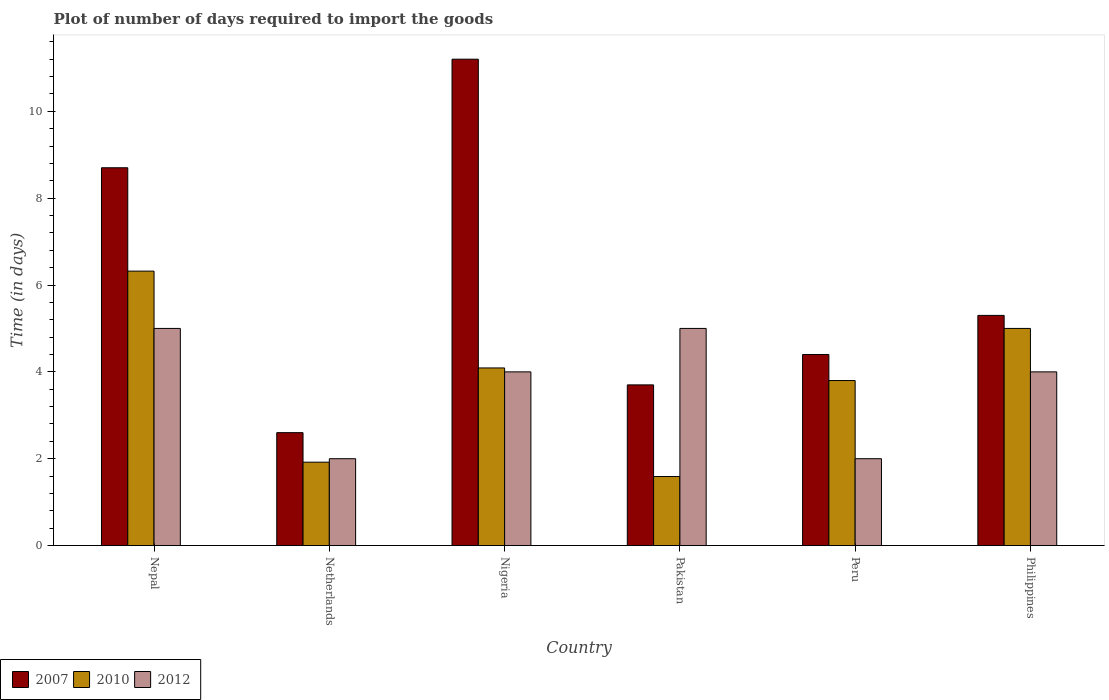Are the number of bars on each tick of the X-axis equal?
Make the answer very short. Yes. How many bars are there on the 5th tick from the right?
Offer a very short reply. 3. What is the label of the 5th group of bars from the left?
Offer a very short reply. Peru. What is the time required to import goods in 2007 in Nepal?
Give a very brief answer. 8.7. Across all countries, what is the minimum time required to import goods in 2010?
Offer a terse response. 1.59. In which country was the time required to import goods in 2007 maximum?
Ensure brevity in your answer.  Nigeria. In which country was the time required to import goods in 2007 minimum?
Provide a short and direct response. Netherlands. What is the difference between the time required to import goods in 2012 in Peru and that in Philippines?
Offer a terse response. -2. What is the difference between the time required to import goods in 2012 in Nepal and the time required to import goods in 2007 in Philippines?
Provide a succinct answer. -0.3. What is the average time required to import goods in 2010 per country?
Make the answer very short. 3.79. What is the difference between the time required to import goods of/in 2007 and time required to import goods of/in 2010 in Philippines?
Make the answer very short. 0.3. In how many countries, is the time required to import goods in 2007 greater than 8.8 days?
Provide a short and direct response. 1. What is the ratio of the time required to import goods in 2007 in Netherlands to that in Nigeria?
Ensure brevity in your answer.  0.23. Is the time required to import goods in 2007 in Nepal less than that in Nigeria?
Offer a very short reply. Yes. Is the difference between the time required to import goods in 2007 in Pakistan and Peru greater than the difference between the time required to import goods in 2010 in Pakistan and Peru?
Provide a succinct answer. Yes. What is the difference between the highest and the lowest time required to import goods in 2010?
Ensure brevity in your answer.  4.73. Is the sum of the time required to import goods in 2007 in Netherlands and Philippines greater than the maximum time required to import goods in 2010 across all countries?
Offer a terse response. Yes. What does the 3rd bar from the left in Pakistan represents?
Provide a short and direct response. 2012. How many bars are there?
Ensure brevity in your answer.  18. Are all the bars in the graph horizontal?
Keep it short and to the point. No. How many countries are there in the graph?
Your answer should be compact. 6. Are the values on the major ticks of Y-axis written in scientific E-notation?
Provide a succinct answer. No. Does the graph contain any zero values?
Offer a very short reply. No. How many legend labels are there?
Give a very brief answer. 3. How are the legend labels stacked?
Provide a short and direct response. Horizontal. What is the title of the graph?
Your answer should be very brief. Plot of number of days required to import the goods. Does "1986" appear as one of the legend labels in the graph?
Your answer should be very brief. No. What is the label or title of the X-axis?
Provide a succinct answer. Country. What is the label or title of the Y-axis?
Give a very brief answer. Time (in days). What is the Time (in days) of 2010 in Nepal?
Your answer should be very brief. 6.32. What is the Time (in days) in 2007 in Netherlands?
Give a very brief answer. 2.6. What is the Time (in days) in 2010 in Netherlands?
Provide a short and direct response. 1.92. What is the Time (in days) in 2012 in Netherlands?
Offer a very short reply. 2. What is the Time (in days) of 2010 in Nigeria?
Offer a terse response. 4.09. What is the Time (in days) in 2012 in Nigeria?
Make the answer very short. 4. What is the Time (in days) in 2007 in Pakistan?
Keep it short and to the point. 3.7. What is the Time (in days) in 2010 in Pakistan?
Offer a terse response. 1.59. What is the Time (in days) in 2007 in Peru?
Make the answer very short. 4.4. What is the Time (in days) in 2010 in Peru?
Provide a succinct answer. 3.8. What is the Time (in days) in 2010 in Philippines?
Your response must be concise. 5. What is the Time (in days) of 2012 in Philippines?
Provide a succinct answer. 4. Across all countries, what is the maximum Time (in days) of 2007?
Keep it short and to the point. 11.2. Across all countries, what is the maximum Time (in days) of 2010?
Offer a terse response. 6.32. Across all countries, what is the maximum Time (in days) of 2012?
Offer a very short reply. 5. Across all countries, what is the minimum Time (in days) of 2007?
Keep it short and to the point. 2.6. Across all countries, what is the minimum Time (in days) in 2010?
Offer a very short reply. 1.59. Across all countries, what is the minimum Time (in days) of 2012?
Your answer should be compact. 2. What is the total Time (in days) of 2007 in the graph?
Make the answer very short. 35.9. What is the total Time (in days) in 2010 in the graph?
Ensure brevity in your answer.  22.72. What is the total Time (in days) of 2012 in the graph?
Give a very brief answer. 22. What is the difference between the Time (in days) in 2007 in Nepal and that in Netherlands?
Offer a very short reply. 6.1. What is the difference between the Time (in days) of 2012 in Nepal and that in Netherlands?
Offer a terse response. 3. What is the difference between the Time (in days) of 2010 in Nepal and that in Nigeria?
Your response must be concise. 2.23. What is the difference between the Time (in days) in 2007 in Nepal and that in Pakistan?
Ensure brevity in your answer.  5. What is the difference between the Time (in days) of 2010 in Nepal and that in Pakistan?
Offer a very short reply. 4.73. What is the difference between the Time (in days) in 2010 in Nepal and that in Peru?
Give a very brief answer. 2.52. What is the difference between the Time (in days) in 2010 in Nepal and that in Philippines?
Keep it short and to the point. 1.32. What is the difference between the Time (in days) in 2012 in Nepal and that in Philippines?
Your answer should be very brief. 1. What is the difference between the Time (in days) in 2007 in Netherlands and that in Nigeria?
Your response must be concise. -8.6. What is the difference between the Time (in days) in 2010 in Netherlands and that in Nigeria?
Keep it short and to the point. -2.17. What is the difference between the Time (in days) in 2007 in Netherlands and that in Pakistan?
Your answer should be compact. -1.1. What is the difference between the Time (in days) in 2010 in Netherlands and that in Pakistan?
Your answer should be compact. 0.33. What is the difference between the Time (in days) of 2012 in Netherlands and that in Pakistan?
Your response must be concise. -3. What is the difference between the Time (in days) of 2007 in Netherlands and that in Peru?
Ensure brevity in your answer.  -1.8. What is the difference between the Time (in days) of 2010 in Netherlands and that in Peru?
Give a very brief answer. -1.88. What is the difference between the Time (in days) in 2010 in Netherlands and that in Philippines?
Provide a succinct answer. -3.08. What is the difference between the Time (in days) of 2007 in Nigeria and that in Pakistan?
Provide a succinct answer. 7.5. What is the difference between the Time (in days) of 2010 in Nigeria and that in Peru?
Offer a very short reply. 0.29. What is the difference between the Time (in days) of 2012 in Nigeria and that in Peru?
Offer a very short reply. 2. What is the difference between the Time (in days) in 2010 in Nigeria and that in Philippines?
Keep it short and to the point. -0.91. What is the difference between the Time (in days) of 2012 in Nigeria and that in Philippines?
Offer a very short reply. 0. What is the difference between the Time (in days) in 2007 in Pakistan and that in Peru?
Ensure brevity in your answer.  -0.7. What is the difference between the Time (in days) of 2010 in Pakistan and that in Peru?
Offer a very short reply. -2.21. What is the difference between the Time (in days) of 2007 in Pakistan and that in Philippines?
Ensure brevity in your answer.  -1.6. What is the difference between the Time (in days) of 2010 in Pakistan and that in Philippines?
Your answer should be very brief. -3.41. What is the difference between the Time (in days) in 2012 in Peru and that in Philippines?
Provide a succinct answer. -2. What is the difference between the Time (in days) of 2007 in Nepal and the Time (in days) of 2010 in Netherlands?
Keep it short and to the point. 6.78. What is the difference between the Time (in days) in 2007 in Nepal and the Time (in days) in 2012 in Netherlands?
Your answer should be compact. 6.7. What is the difference between the Time (in days) in 2010 in Nepal and the Time (in days) in 2012 in Netherlands?
Offer a terse response. 4.32. What is the difference between the Time (in days) in 2007 in Nepal and the Time (in days) in 2010 in Nigeria?
Your answer should be very brief. 4.61. What is the difference between the Time (in days) of 2010 in Nepal and the Time (in days) of 2012 in Nigeria?
Ensure brevity in your answer.  2.32. What is the difference between the Time (in days) of 2007 in Nepal and the Time (in days) of 2010 in Pakistan?
Provide a short and direct response. 7.11. What is the difference between the Time (in days) of 2010 in Nepal and the Time (in days) of 2012 in Pakistan?
Offer a very short reply. 1.32. What is the difference between the Time (in days) in 2007 in Nepal and the Time (in days) in 2012 in Peru?
Ensure brevity in your answer.  6.7. What is the difference between the Time (in days) in 2010 in Nepal and the Time (in days) in 2012 in Peru?
Your answer should be compact. 4.32. What is the difference between the Time (in days) in 2007 in Nepal and the Time (in days) in 2010 in Philippines?
Provide a short and direct response. 3.7. What is the difference between the Time (in days) of 2010 in Nepal and the Time (in days) of 2012 in Philippines?
Your answer should be compact. 2.32. What is the difference between the Time (in days) of 2007 in Netherlands and the Time (in days) of 2010 in Nigeria?
Provide a short and direct response. -1.49. What is the difference between the Time (in days) in 2010 in Netherlands and the Time (in days) in 2012 in Nigeria?
Your response must be concise. -2.08. What is the difference between the Time (in days) in 2007 in Netherlands and the Time (in days) in 2010 in Pakistan?
Your answer should be compact. 1.01. What is the difference between the Time (in days) of 2007 in Netherlands and the Time (in days) of 2012 in Pakistan?
Give a very brief answer. -2.4. What is the difference between the Time (in days) of 2010 in Netherlands and the Time (in days) of 2012 in Pakistan?
Your answer should be compact. -3.08. What is the difference between the Time (in days) in 2007 in Netherlands and the Time (in days) in 2010 in Peru?
Provide a short and direct response. -1.2. What is the difference between the Time (in days) of 2007 in Netherlands and the Time (in days) of 2012 in Peru?
Provide a succinct answer. 0.6. What is the difference between the Time (in days) in 2010 in Netherlands and the Time (in days) in 2012 in Peru?
Keep it short and to the point. -0.08. What is the difference between the Time (in days) in 2007 in Netherlands and the Time (in days) in 2010 in Philippines?
Offer a terse response. -2.4. What is the difference between the Time (in days) of 2007 in Netherlands and the Time (in days) of 2012 in Philippines?
Give a very brief answer. -1.4. What is the difference between the Time (in days) of 2010 in Netherlands and the Time (in days) of 2012 in Philippines?
Give a very brief answer. -2.08. What is the difference between the Time (in days) of 2007 in Nigeria and the Time (in days) of 2010 in Pakistan?
Your response must be concise. 9.61. What is the difference between the Time (in days) in 2010 in Nigeria and the Time (in days) in 2012 in Pakistan?
Keep it short and to the point. -0.91. What is the difference between the Time (in days) in 2007 in Nigeria and the Time (in days) in 2010 in Peru?
Your answer should be compact. 7.4. What is the difference between the Time (in days) of 2010 in Nigeria and the Time (in days) of 2012 in Peru?
Offer a terse response. 2.09. What is the difference between the Time (in days) in 2007 in Nigeria and the Time (in days) in 2010 in Philippines?
Ensure brevity in your answer.  6.2. What is the difference between the Time (in days) of 2010 in Nigeria and the Time (in days) of 2012 in Philippines?
Provide a short and direct response. 0.09. What is the difference between the Time (in days) in 2007 in Pakistan and the Time (in days) in 2010 in Peru?
Offer a very short reply. -0.1. What is the difference between the Time (in days) in 2007 in Pakistan and the Time (in days) in 2012 in Peru?
Your response must be concise. 1.7. What is the difference between the Time (in days) of 2010 in Pakistan and the Time (in days) of 2012 in Peru?
Keep it short and to the point. -0.41. What is the difference between the Time (in days) of 2010 in Pakistan and the Time (in days) of 2012 in Philippines?
Your answer should be very brief. -2.41. What is the difference between the Time (in days) in 2007 in Peru and the Time (in days) in 2010 in Philippines?
Your answer should be very brief. -0.6. What is the difference between the Time (in days) of 2007 in Peru and the Time (in days) of 2012 in Philippines?
Keep it short and to the point. 0.4. What is the difference between the Time (in days) in 2010 in Peru and the Time (in days) in 2012 in Philippines?
Your answer should be compact. -0.2. What is the average Time (in days) in 2007 per country?
Your answer should be very brief. 5.98. What is the average Time (in days) of 2010 per country?
Make the answer very short. 3.79. What is the average Time (in days) in 2012 per country?
Offer a terse response. 3.67. What is the difference between the Time (in days) in 2007 and Time (in days) in 2010 in Nepal?
Offer a very short reply. 2.38. What is the difference between the Time (in days) of 2007 and Time (in days) of 2012 in Nepal?
Ensure brevity in your answer.  3.7. What is the difference between the Time (in days) in 2010 and Time (in days) in 2012 in Nepal?
Ensure brevity in your answer.  1.32. What is the difference between the Time (in days) in 2007 and Time (in days) in 2010 in Netherlands?
Provide a short and direct response. 0.68. What is the difference between the Time (in days) in 2007 and Time (in days) in 2012 in Netherlands?
Ensure brevity in your answer.  0.6. What is the difference between the Time (in days) in 2010 and Time (in days) in 2012 in Netherlands?
Your answer should be compact. -0.08. What is the difference between the Time (in days) in 2007 and Time (in days) in 2010 in Nigeria?
Your answer should be very brief. 7.11. What is the difference between the Time (in days) of 2010 and Time (in days) of 2012 in Nigeria?
Provide a succinct answer. 0.09. What is the difference between the Time (in days) of 2007 and Time (in days) of 2010 in Pakistan?
Provide a short and direct response. 2.11. What is the difference between the Time (in days) of 2010 and Time (in days) of 2012 in Pakistan?
Give a very brief answer. -3.41. What is the difference between the Time (in days) in 2007 and Time (in days) in 2010 in Peru?
Provide a succinct answer. 0.6. What is the difference between the Time (in days) of 2007 and Time (in days) of 2012 in Peru?
Offer a very short reply. 2.4. What is the difference between the Time (in days) in 2010 and Time (in days) in 2012 in Peru?
Your answer should be compact. 1.8. What is the difference between the Time (in days) in 2010 and Time (in days) in 2012 in Philippines?
Make the answer very short. 1. What is the ratio of the Time (in days) of 2007 in Nepal to that in Netherlands?
Your response must be concise. 3.35. What is the ratio of the Time (in days) in 2010 in Nepal to that in Netherlands?
Keep it short and to the point. 3.29. What is the ratio of the Time (in days) of 2007 in Nepal to that in Nigeria?
Ensure brevity in your answer.  0.78. What is the ratio of the Time (in days) in 2010 in Nepal to that in Nigeria?
Offer a terse response. 1.55. What is the ratio of the Time (in days) of 2007 in Nepal to that in Pakistan?
Your answer should be compact. 2.35. What is the ratio of the Time (in days) in 2010 in Nepal to that in Pakistan?
Offer a terse response. 3.97. What is the ratio of the Time (in days) of 2012 in Nepal to that in Pakistan?
Provide a succinct answer. 1. What is the ratio of the Time (in days) in 2007 in Nepal to that in Peru?
Make the answer very short. 1.98. What is the ratio of the Time (in days) of 2010 in Nepal to that in Peru?
Ensure brevity in your answer.  1.66. What is the ratio of the Time (in days) in 2007 in Nepal to that in Philippines?
Give a very brief answer. 1.64. What is the ratio of the Time (in days) in 2010 in Nepal to that in Philippines?
Offer a terse response. 1.26. What is the ratio of the Time (in days) in 2012 in Nepal to that in Philippines?
Make the answer very short. 1.25. What is the ratio of the Time (in days) of 2007 in Netherlands to that in Nigeria?
Your answer should be compact. 0.23. What is the ratio of the Time (in days) of 2010 in Netherlands to that in Nigeria?
Your response must be concise. 0.47. What is the ratio of the Time (in days) of 2007 in Netherlands to that in Pakistan?
Offer a very short reply. 0.7. What is the ratio of the Time (in days) of 2010 in Netherlands to that in Pakistan?
Provide a succinct answer. 1.21. What is the ratio of the Time (in days) of 2012 in Netherlands to that in Pakistan?
Keep it short and to the point. 0.4. What is the ratio of the Time (in days) of 2007 in Netherlands to that in Peru?
Your response must be concise. 0.59. What is the ratio of the Time (in days) of 2010 in Netherlands to that in Peru?
Your answer should be very brief. 0.51. What is the ratio of the Time (in days) in 2012 in Netherlands to that in Peru?
Provide a short and direct response. 1. What is the ratio of the Time (in days) of 2007 in Netherlands to that in Philippines?
Your answer should be very brief. 0.49. What is the ratio of the Time (in days) of 2010 in Netherlands to that in Philippines?
Your answer should be compact. 0.38. What is the ratio of the Time (in days) of 2007 in Nigeria to that in Pakistan?
Ensure brevity in your answer.  3.03. What is the ratio of the Time (in days) of 2010 in Nigeria to that in Pakistan?
Your answer should be compact. 2.57. What is the ratio of the Time (in days) in 2007 in Nigeria to that in Peru?
Provide a succinct answer. 2.55. What is the ratio of the Time (in days) of 2010 in Nigeria to that in Peru?
Your answer should be very brief. 1.08. What is the ratio of the Time (in days) of 2007 in Nigeria to that in Philippines?
Your answer should be compact. 2.11. What is the ratio of the Time (in days) of 2010 in Nigeria to that in Philippines?
Keep it short and to the point. 0.82. What is the ratio of the Time (in days) of 2007 in Pakistan to that in Peru?
Your response must be concise. 0.84. What is the ratio of the Time (in days) of 2010 in Pakistan to that in Peru?
Provide a succinct answer. 0.42. What is the ratio of the Time (in days) in 2007 in Pakistan to that in Philippines?
Your response must be concise. 0.7. What is the ratio of the Time (in days) in 2010 in Pakistan to that in Philippines?
Provide a short and direct response. 0.32. What is the ratio of the Time (in days) in 2012 in Pakistan to that in Philippines?
Make the answer very short. 1.25. What is the ratio of the Time (in days) in 2007 in Peru to that in Philippines?
Offer a very short reply. 0.83. What is the ratio of the Time (in days) of 2010 in Peru to that in Philippines?
Offer a terse response. 0.76. What is the difference between the highest and the second highest Time (in days) of 2007?
Offer a very short reply. 2.5. What is the difference between the highest and the second highest Time (in days) in 2010?
Your answer should be compact. 1.32. What is the difference between the highest and the lowest Time (in days) in 2010?
Your answer should be very brief. 4.73. What is the difference between the highest and the lowest Time (in days) in 2012?
Ensure brevity in your answer.  3. 